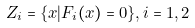<formula> <loc_0><loc_0><loc_500><loc_500>Z _ { i } = \{ { x } | F _ { i } ( { x } ) = 0 \} , i = 1 , 2</formula> 